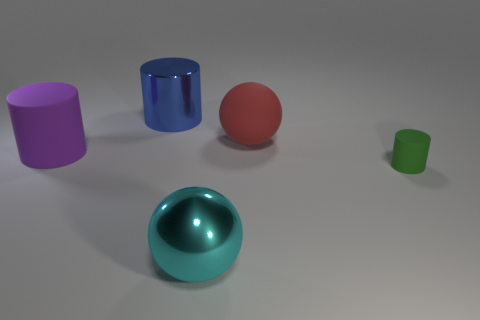Add 1 blue shiny cylinders. How many objects exist? 6 Subtract all balls. How many objects are left? 3 Add 4 big purple objects. How many big purple objects exist? 5 Subtract 0 red cubes. How many objects are left? 5 Subtract all tiny cyan blocks. Subtract all purple cylinders. How many objects are left? 4 Add 4 green matte objects. How many green matte objects are left? 5 